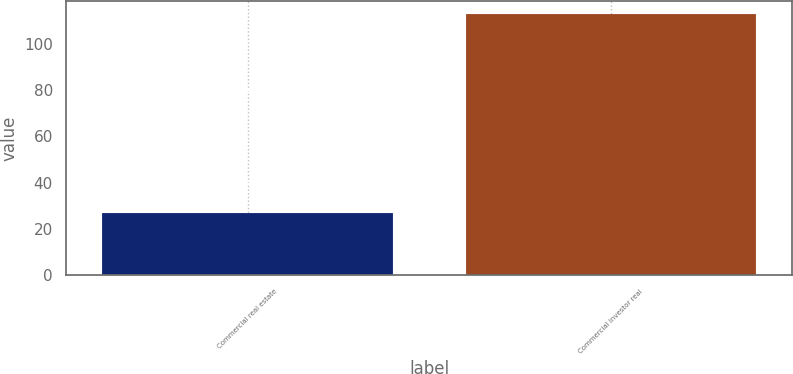<chart> <loc_0><loc_0><loc_500><loc_500><bar_chart><fcel>Commercial real estate<fcel>Commercial investor real<nl><fcel>27<fcel>113<nl></chart> 